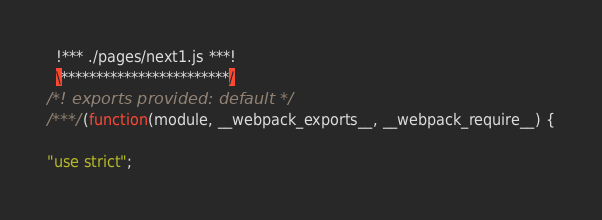<code> <loc_0><loc_0><loc_500><loc_500><_JavaScript_>  !*** ./pages/next1.js ***!
  \************************/
/*! exports provided: default */
/***/ (function(module, __webpack_exports__, __webpack_require__) {

"use strict";</code> 